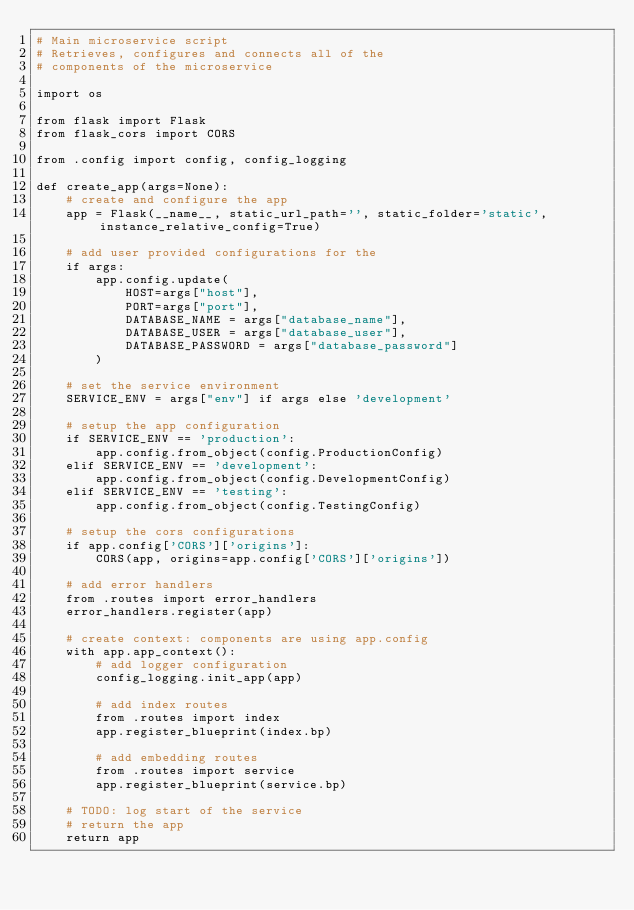<code> <loc_0><loc_0><loc_500><loc_500><_Python_># Main microservice script
# Retrieves, configures and connects all of the
# components of the microservice

import os

from flask import Flask
from flask_cors import CORS

from .config import config, config_logging

def create_app(args=None):
    # create and configure the app
    app = Flask(__name__, static_url_path='', static_folder='static', instance_relative_config=True)

    # add user provided configurations for the
    if args:
        app.config.update(
            HOST=args["host"],
            PORT=args["port"],
            DATABASE_NAME = args["database_name"],
            DATABASE_USER = args["database_user"],
            DATABASE_PASSWORD = args["database_password"]
        )

    # set the service environment
    SERVICE_ENV = args["env"] if args else 'development'

    # setup the app configuration
    if SERVICE_ENV == 'production':
        app.config.from_object(config.ProductionConfig)
    elif SERVICE_ENV == 'development':
        app.config.from_object(config.DevelopmentConfig)
    elif SERVICE_ENV == 'testing':
        app.config.from_object(config.TestingConfig)

    # setup the cors configurations
    if app.config['CORS']['origins']:
        CORS(app, origins=app.config['CORS']['origins'])

    # add error handlers
    from .routes import error_handlers
    error_handlers.register(app)

    # create context: components are using app.config
    with app.app_context():
        # add logger configuration
        config_logging.init_app(app)

        # add index routes
        from .routes import index
        app.register_blueprint(index.bp)

        # add embedding routes
        from .routes import service
        app.register_blueprint(service.bp)

    # TODO: log start of the service
    # return the app
    return app
</code> 